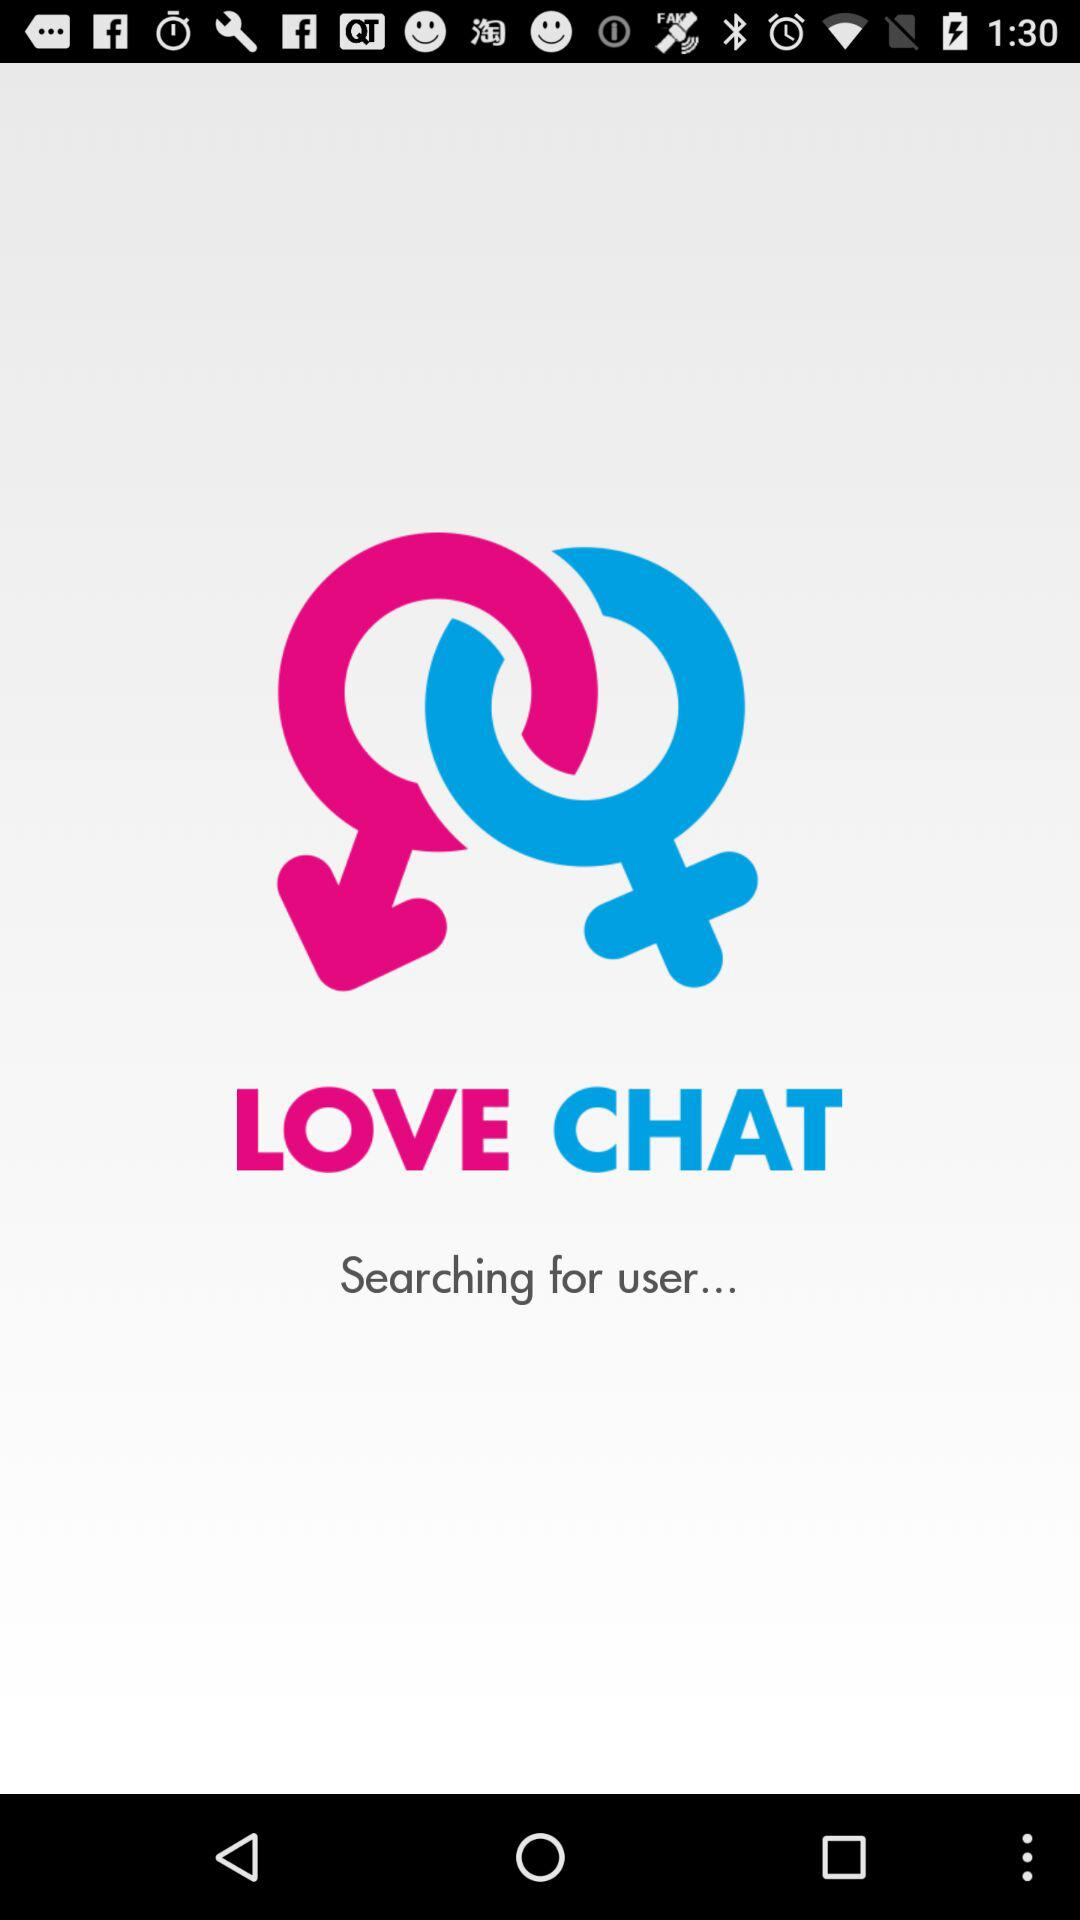What is the application name? The application name is "LOVE CHAT". 